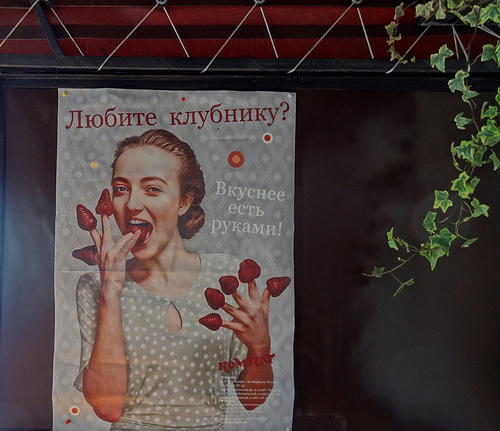<image>
Is there a finger in the strawberry? Yes. The finger is contained within or inside the strawberry, showing a containment relationship. 